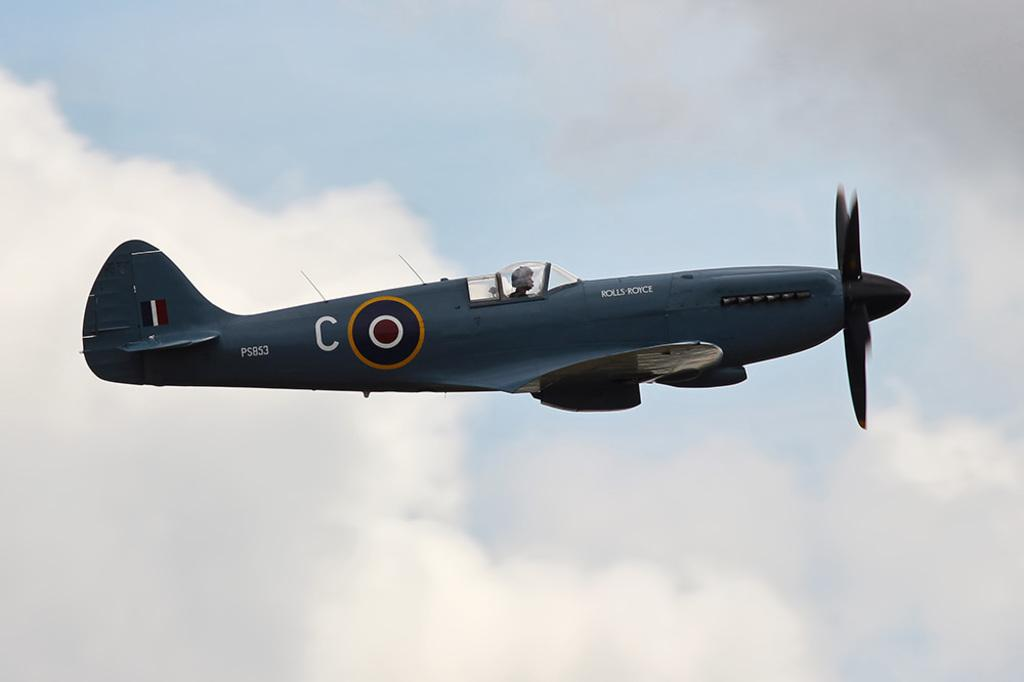Provide a one-sentence caption for the provided image. A world war 2 plane flies with PS853 markings near the tail. 